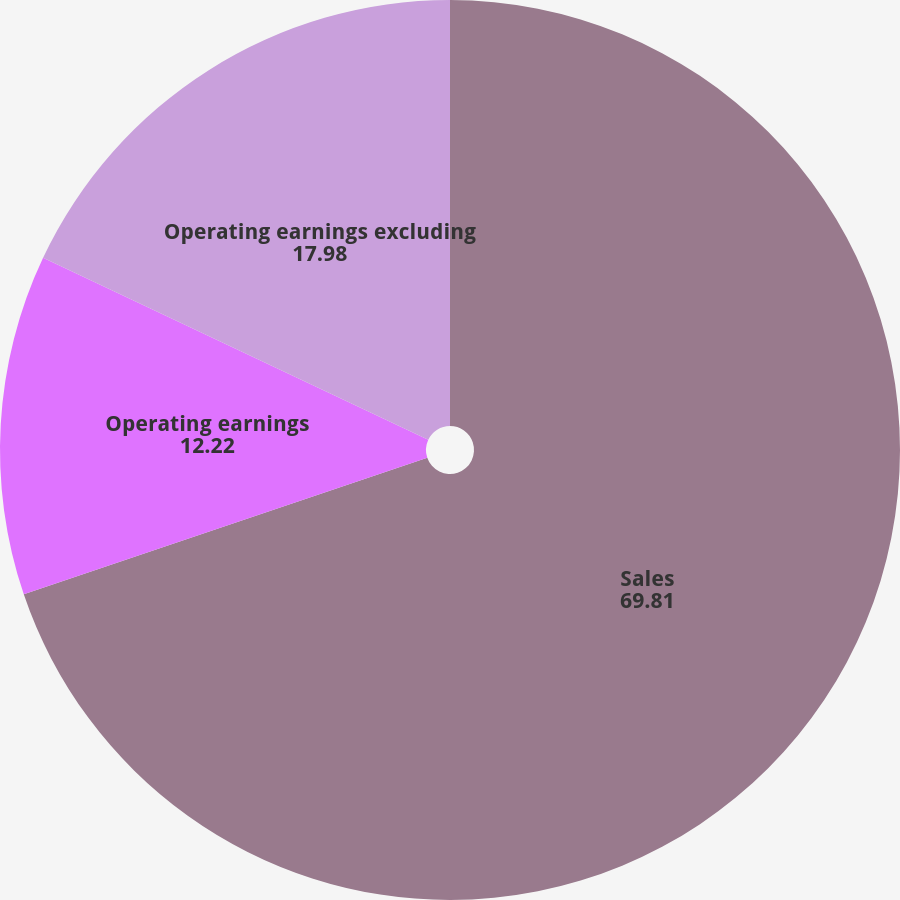Convert chart to OTSL. <chart><loc_0><loc_0><loc_500><loc_500><pie_chart><fcel>Sales<fcel>Operating earnings<fcel>Operating earnings excluding<nl><fcel>69.81%<fcel>12.22%<fcel>17.98%<nl></chart> 